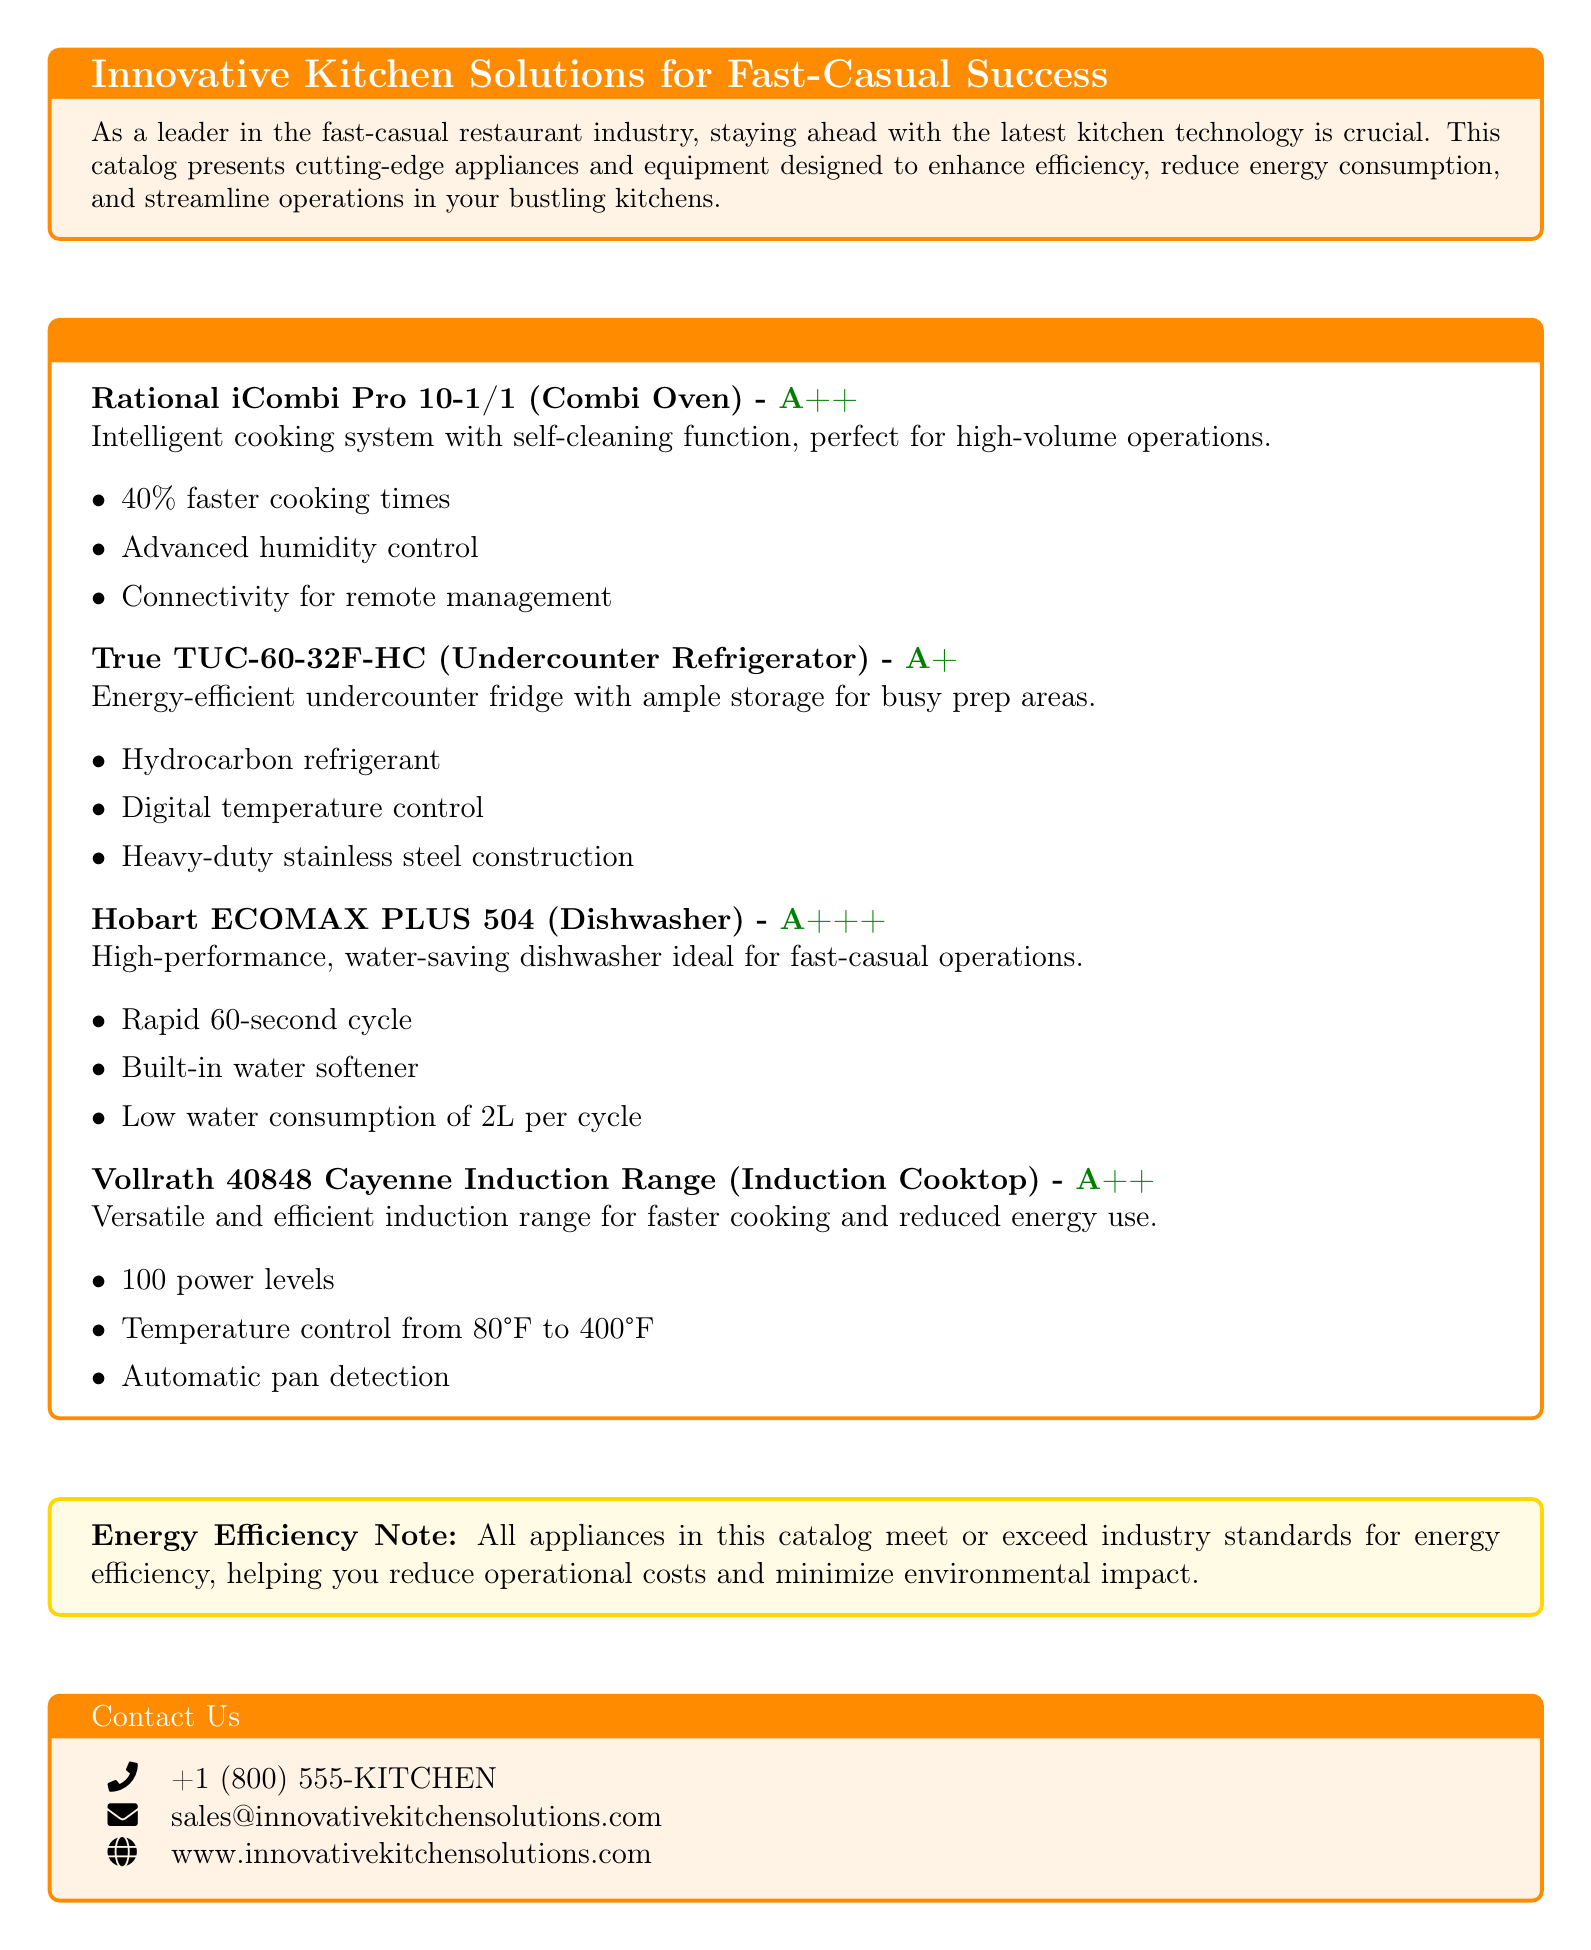What is the energy efficiency rating of the Rational iCombi Pro 10-1/1? The energy efficiency rating is an important characteristic for appliances, and for the Rational iCombi Pro 10-1/1, it is noted as A++.
Answer: A++ What feature allows the True TUC-60-32F-HC to regulate its temperature? The True TUC-60-32F-HC has a digital temperature control feature to maintain the desired temperature effectively.
Answer: Digital temperature control What is the rapid cycle time of the Hobart ECOMAX PLUS 504 dishwasher? The cycle time is a critical factor for efficiency in a fast-casual setting, and the Hobart ECOMAX PLUS 504 has a rapid cycle time of 60 seconds.
Answer: 60 seconds How many power levels does the Vollrath 40848 Cayenne Induction Range offer? Understanding power levels helps in differentiating appliances, and the Vollrath 40848 offers 100 power levels for cooking versatility.
Answer: 100 power levels What is the main benefit of the advanced humidity control in the Rational iCombi Pro 10-1/1? Advanced humidity control aids in cooking precision, allowing for improved meal quality, especially in high-volume operations.
Answer: Cooking precision What type of refrigerant does the True TUC-60-32F-HC use? The type of refrigerant is significant for energy efficiency standards, and the True TUC-60-32F-HC uses a hydrocarbon refrigerant.
Answer: Hydrocarbon refrigerant What is the maximum temperature range of the Vollrath 40848 Cayenne Induction Range? The temperature control range assists chefs in a variety of cooking tasks, with the maximum being 400°F for the Vollrath 40848.
Answer: 400°F What is the water consumption per cycle for the Hobart ECOMAX PLUS 504? Water consumption is a key metric for efficiency, and the Hobart ECOMAX uses 2L per cycle, which is quite low compared to others.
Answer: 2L per cycle What is the purpose of including an energy efficiency note in the catalog? The energy efficiency note emphasizes the importance of reduced operational costs and environmental friendliness for restaurant operations.
Answer: Reduced operational costs and environmental impact 